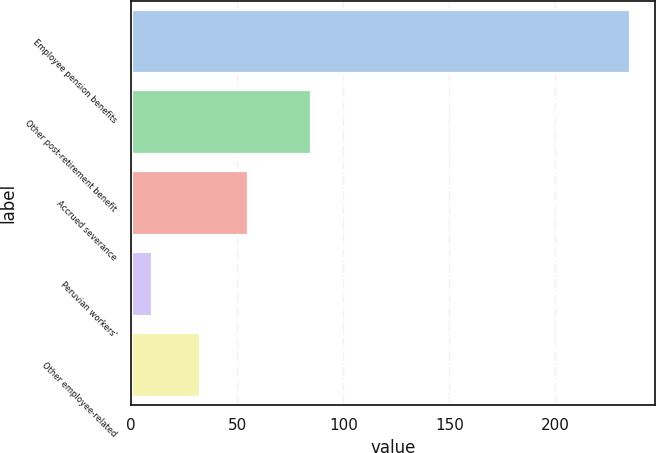<chart> <loc_0><loc_0><loc_500><loc_500><bar_chart><fcel>Employee pension benefits<fcel>Other post-retirement benefit<fcel>Accrued severance<fcel>Peruvian workers'<fcel>Other employee-related<nl><fcel>235<fcel>85<fcel>55<fcel>10<fcel>32.5<nl></chart> 